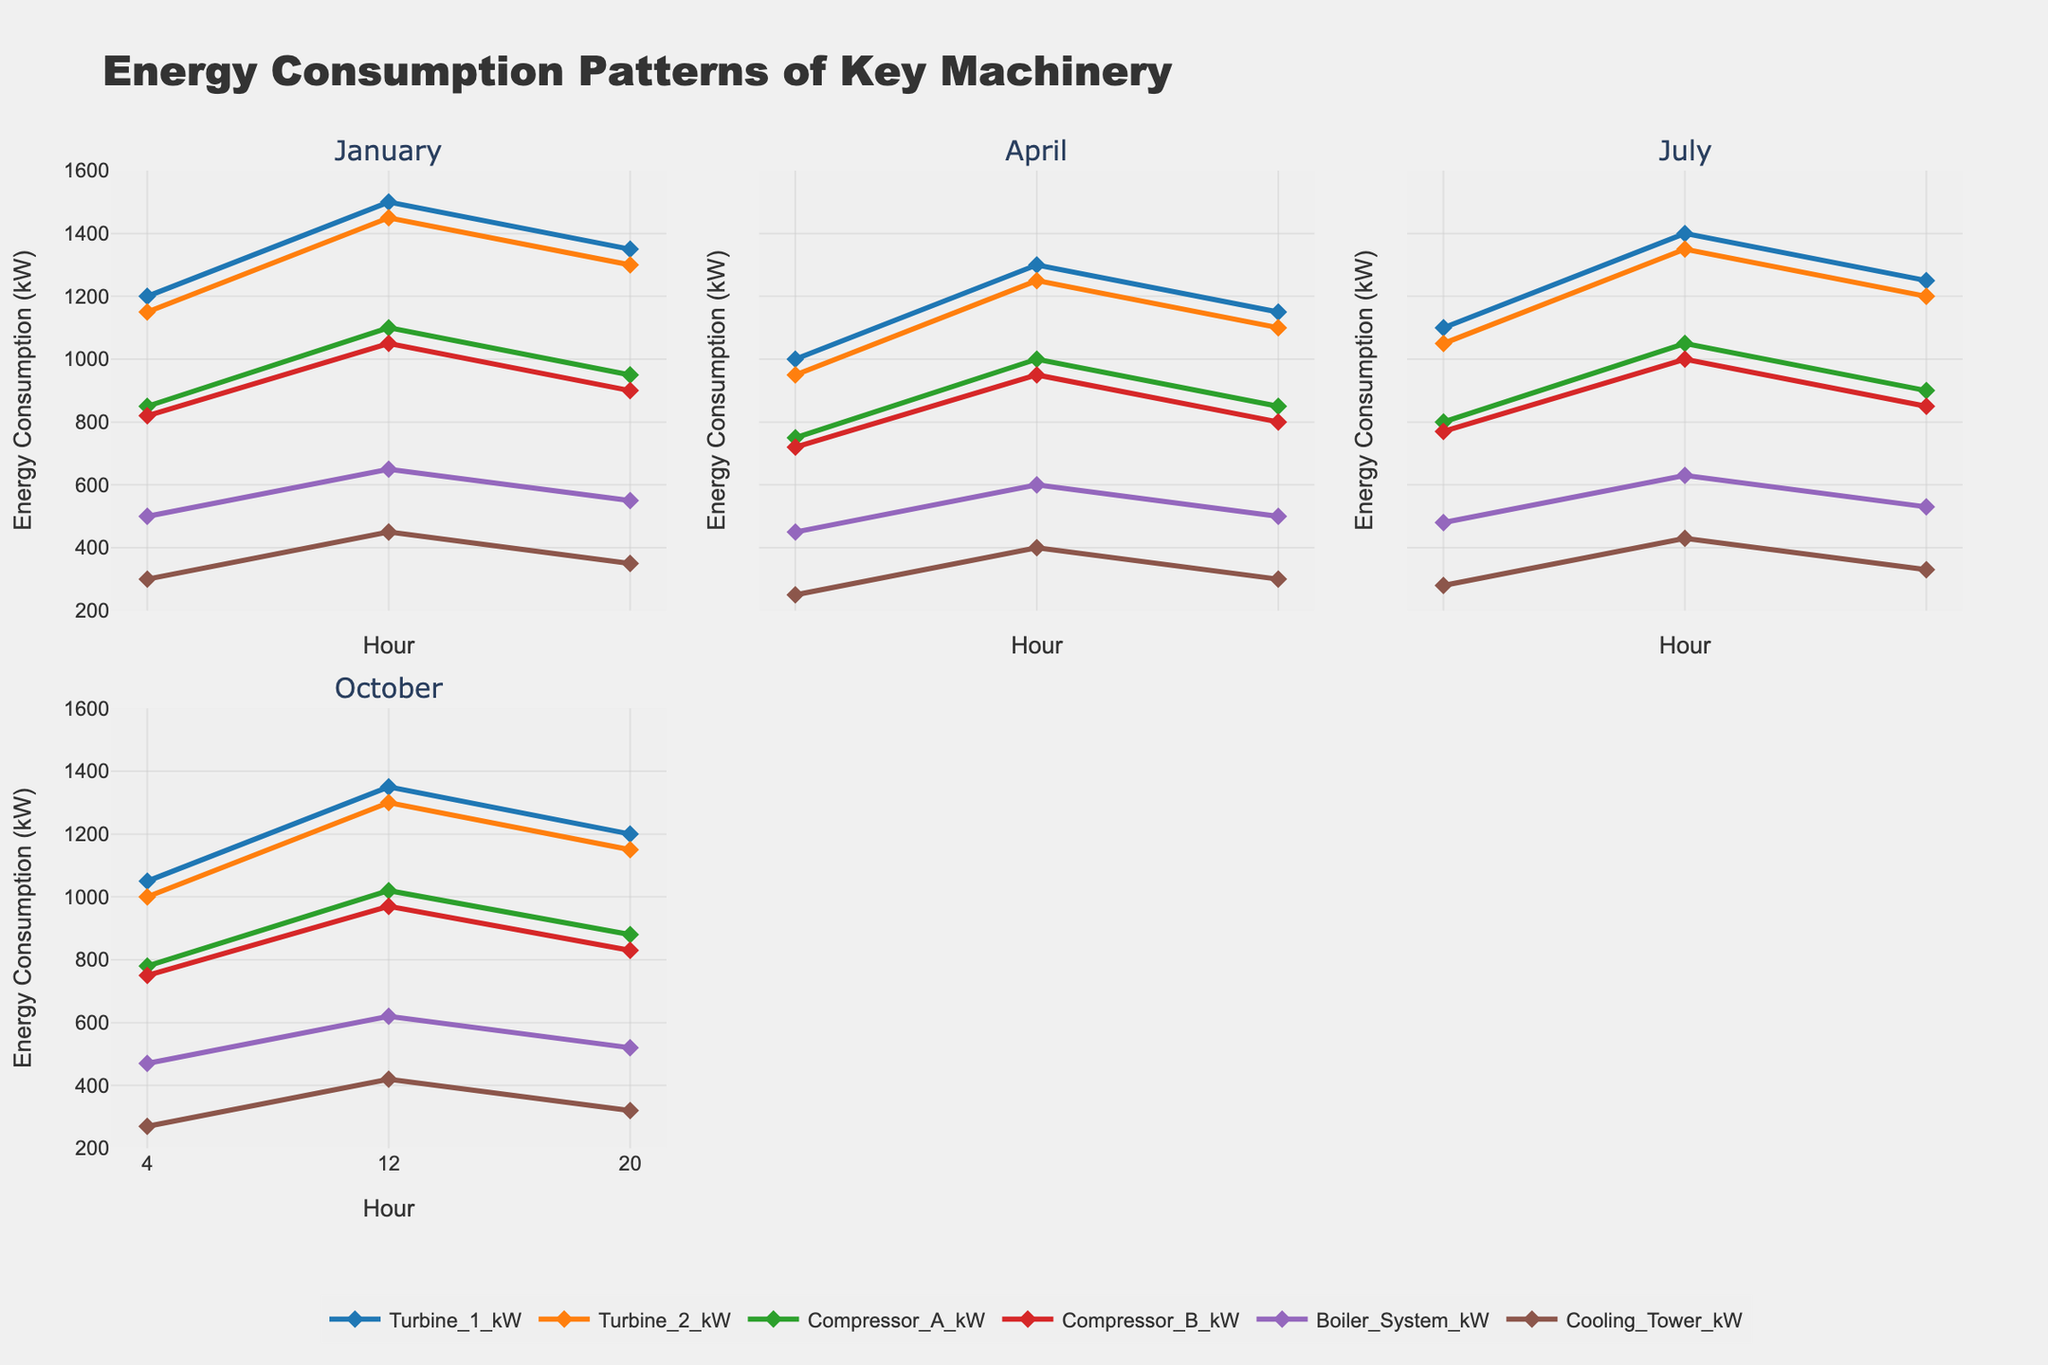What is the title of the plot? The title is located at the top of the plot and provides an overview of the data being visualized.
Answer: Energy Consumption Patterns of Key Machinery Which month shows the highest energy consumption for Turbine_1 at 12 PM? By examining the subplot for each month, look at the data point for Turbine_1 at 12 PM and identify the month with the highest value.
Answer: January What is the energy consumption difference for Compressor_A between 4 AM and 12 PM in April? Locate the energy consumption for Compressor_A at 4 AM (750 kW) and 12 PM (1000 kW) in the April subplot, then subtract the 4 AM value from the 12 PM value.
Answer: 250 kW Compare the energy consumption of the Boiler_System at 4 AM across all months. Which month has the lowest value? Examine each subplot at the 4 AM mark for the Boiler_System and note the values to identify the lowest one.
Answer: April How does the energy consumption pattern of Cooling_Tower at 20 PM vary across the different months? Look at the 20 PM values for Cooling_Tower across all subplots to observe any variations or trends.
Answer: Values range between 250-350 kW with minor variations across months Does Turbine_2 maintain a consistent energy consumption level throughout the day in July compared to other months? Compare the line of Turbine_2 in July at different hours against its lines in other months to see if the pattern or consistency varies.
Answer: No, it shows a peak at 12 PM like other months, but values vary at other hours What's the average energy consumption of Compressor_B across all recorded hours in October? Sum the values of Compressor_B for 4 AM (750 kW), 12 PM (970 kW), and 20 PM (830 kW) in October and divide by 3.
Answer: 850 kW Which machinery exhibits the steepest increase in energy consumption from 4 AM to 12 PM in July? Calculate the increase from 4 AM to 12 PM for each machinery in July and identify the steepest increase.
Answer: Compressor_A 